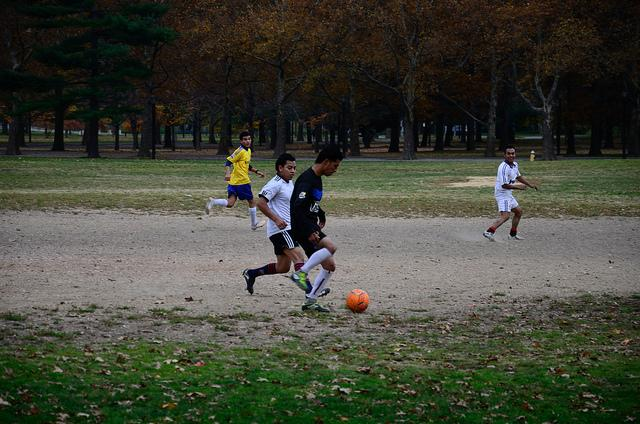What are the boys doing with the orange ball? Please explain your reasoning. kicking it. They are in soccer gear, and it is a soccer ball, and the game is played by kicking it, as using your hands is not allowed in the game. 